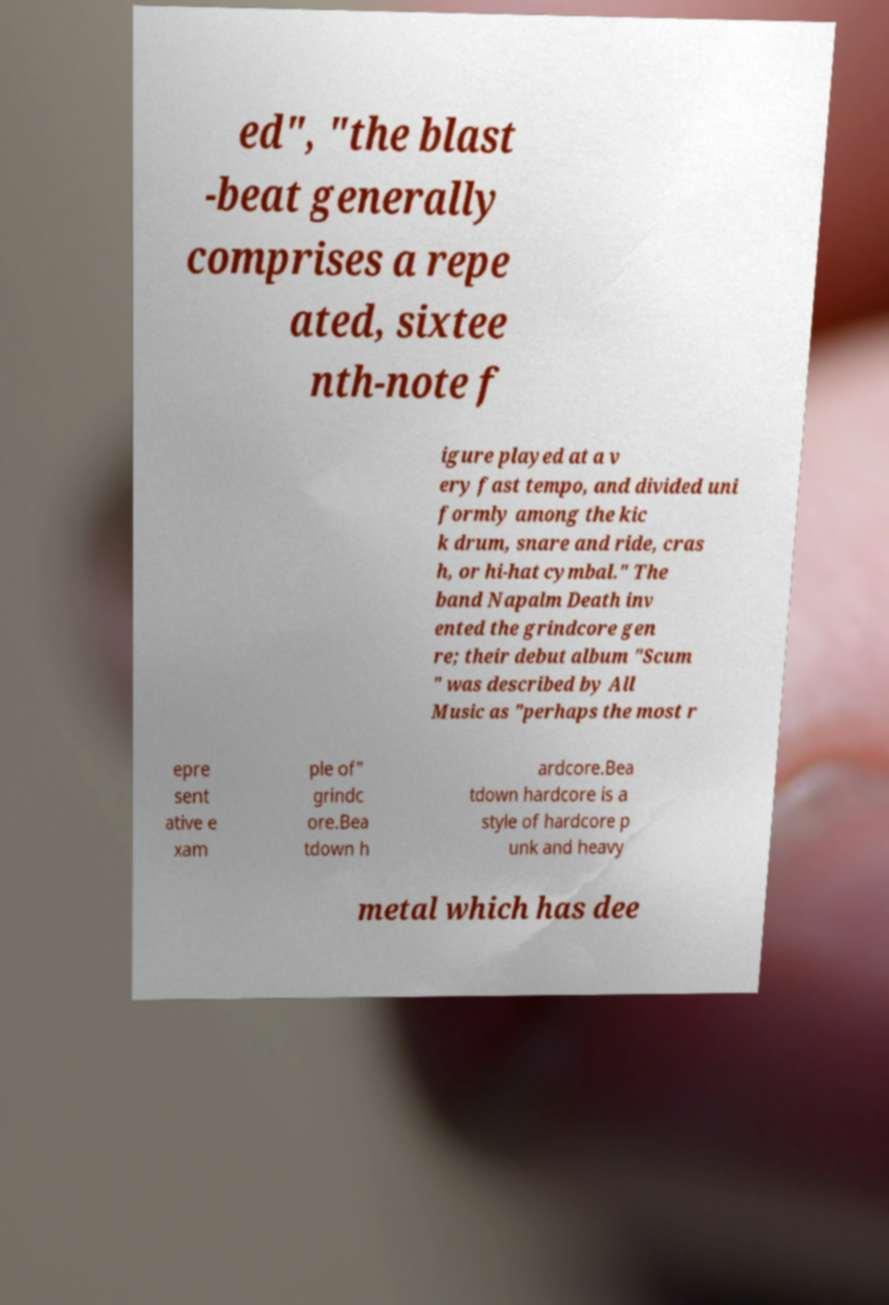There's text embedded in this image that I need extracted. Can you transcribe it verbatim? ed", "the blast -beat generally comprises a repe ated, sixtee nth-note f igure played at a v ery fast tempo, and divided uni formly among the kic k drum, snare and ride, cras h, or hi-hat cymbal." The band Napalm Death inv ented the grindcore gen re; their debut album "Scum " was described by All Music as "perhaps the most r epre sent ative e xam ple of" grindc ore.Bea tdown h ardcore.Bea tdown hardcore is a style of hardcore p unk and heavy metal which has dee 